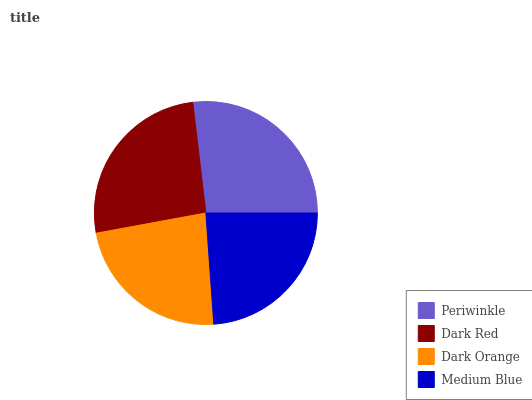Is Dark Orange the minimum?
Answer yes or no. Yes. Is Periwinkle the maximum?
Answer yes or no. Yes. Is Dark Red the minimum?
Answer yes or no. No. Is Dark Red the maximum?
Answer yes or no. No. Is Periwinkle greater than Dark Red?
Answer yes or no. Yes. Is Dark Red less than Periwinkle?
Answer yes or no. Yes. Is Dark Red greater than Periwinkle?
Answer yes or no. No. Is Periwinkle less than Dark Red?
Answer yes or no. No. Is Dark Red the high median?
Answer yes or no. Yes. Is Medium Blue the low median?
Answer yes or no. Yes. Is Dark Orange the high median?
Answer yes or no. No. Is Periwinkle the low median?
Answer yes or no. No. 